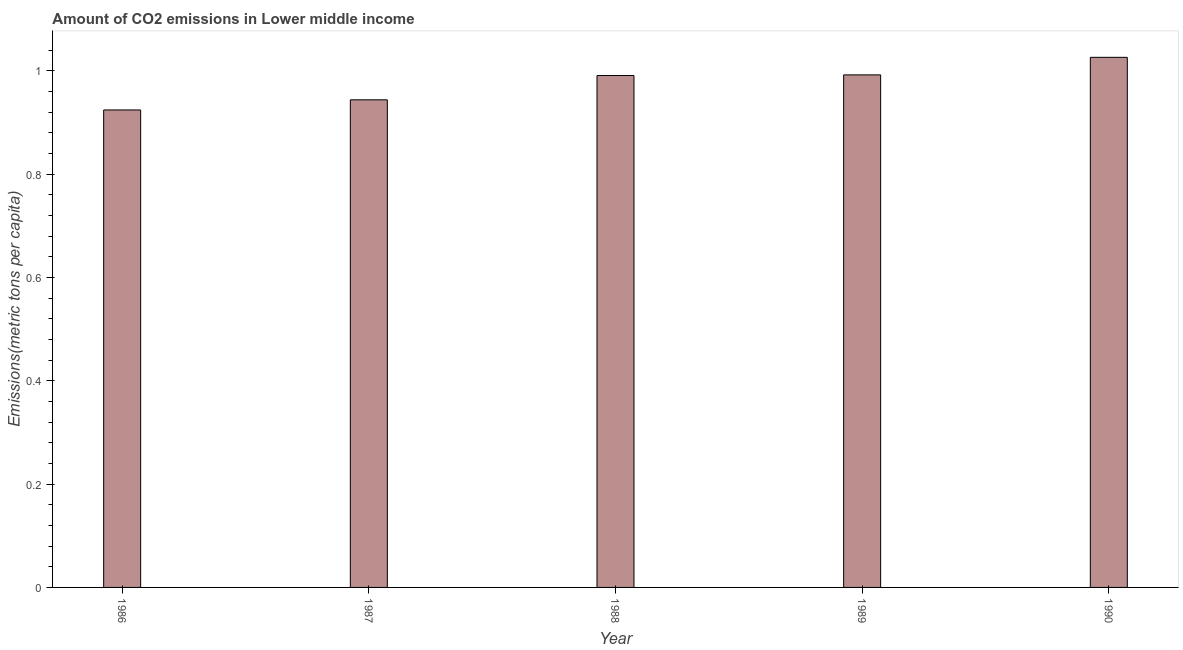What is the title of the graph?
Your response must be concise. Amount of CO2 emissions in Lower middle income. What is the label or title of the X-axis?
Provide a succinct answer. Year. What is the label or title of the Y-axis?
Provide a short and direct response. Emissions(metric tons per capita). What is the amount of co2 emissions in 1990?
Make the answer very short. 1.03. Across all years, what is the maximum amount of co2 emissions?
Your answer should be compact. 1.03. Across all years, what is the minimum amount of co2 emissions?
Give a very brief answer. 0.92. In which year was the amount of co2 emissions maximum?
Provide a short and direct response. 1990. In which year was the amount of co2 emissions minimum?
Offer a very short reply. 1986. What is the sum of the amount of co2 emissions?
Make the answer very short. 4.88. What is the difference between the amount of co2 emissions in 1988 and 1989?
Give a very brief answer. -0. What is the average amount of co2 emissions per year?
Your response must be concise. 0.97. What is the median amount of co2 emissions?
Make the answer very short. 0.99. What is the ratio of the amount of co2 emissions in 1986 to that in 1990?
Offer a very short reply. 0.9. Is the difference between the amount of co2 emissions in 1988 and 1989 greater than the difference between any two years?
Provide a short and direct response. No. What is the difference between the highest and the second highest amount of co2 emissions?
Provide a succinct answer. 0.03. In how many years, is the amount of co2 emissions greater than the average amount of co2 emissions taken over all years?
Offer a very short reply. 3. How many years are there in the graph?
Provide a succinct answer. 5. What is the difference between two consecutive major ticks on the Y-axis?
Offer a terse response. 0.2. Are the values on the major ticks of Y-axis written in scientific E-notation?
Provide a succinct answer. No. What is the Emissions(metric tons per capita) of 1986?
Make the answer very short. 0.92. What is the Emissions(metric tons per capita) of 1987?
Give a very brief answer. 0.94. What is the Emissions(metric tons per capita) of 1988?
Provide a short and direct response. 0.99. What is the Emissions(metric tons per capita) in 1989?
Make the answer very short. 0.99. What is the Emissions(metric tons per capita) in 1990?
Provide a short and direct response. 1.03. What is the difference between the Emissions(metric tons per capita) in 1986 and 1987?
Provide a succinct answer. -0.02. What is the difference between the Emissions(metric tons per capita) in 1986 and 1988?
Make the answer very short. -0.07. What is the difference between the Emissions(metric tons per capita) in 1986 and 1989?
Give a very brief answer. -0.07. What is the difference between the Emissions(metric tons per capita) in 1986 and 1990?
Offer a terse response. -0.1. What is the difference between the Emissions(metric tons per capita) in 1987 and 1988?
Your answer should be compact. -0.05. What is the difference between the Emissions(metric tons per capita) in 1987 and 1989?
Ensure brevity in your answer.  -0.05. What is the difference between the Emissions(metric tons per capita) in 1987 and 1990?
Your answer should be very brief. -0.08. What is the difference between the Emissions(metric tons per capita) in 1988 and 1989?
Your answer should be very brief. -0. What is the difference between the Emissions(metric tons per capita) in 1988 and 1990?
Give a very brief answer. -0.04. What is the difference between the Emissions(metric tons per capita) in 1989 and 1990?
Your response must be concise. -0.03. What is the ratio of the Emissions(metric tons per capita) in 1986 to that in 1988?
Make the answer very short. 0.93. What is the ratio of the Emissions(metric tons per capita) in 1986 to that in 1989?
Make the answer very short. 0.93. What is the ratio of the Emissions(metric tons per capita) in 1986 to that in 1990?
Your answer should be very brief. 0.9. What is the ratio of the Emissions(metric tons per capita) in 1987 to that in 1988?
Give a very brief answer. 0.95. What is the ratio of the Emissions(metric tons per capita) in 1987 to that in 1989?
Provide a short and direct response. 0.95. What is the ratio of the Emissions(metric tons per capita) in 1987 to that in 1990?
Offer a terse response. 0.92. What is the ratio of the Emissions(metric tons per capita) in 1988 to that in 1990?
Your response must be concise. 0.97. What is the ratio of the Emissions(metric tons per capita) in 1989 to that in 1990?
Your answer should be compact. 0.97. 